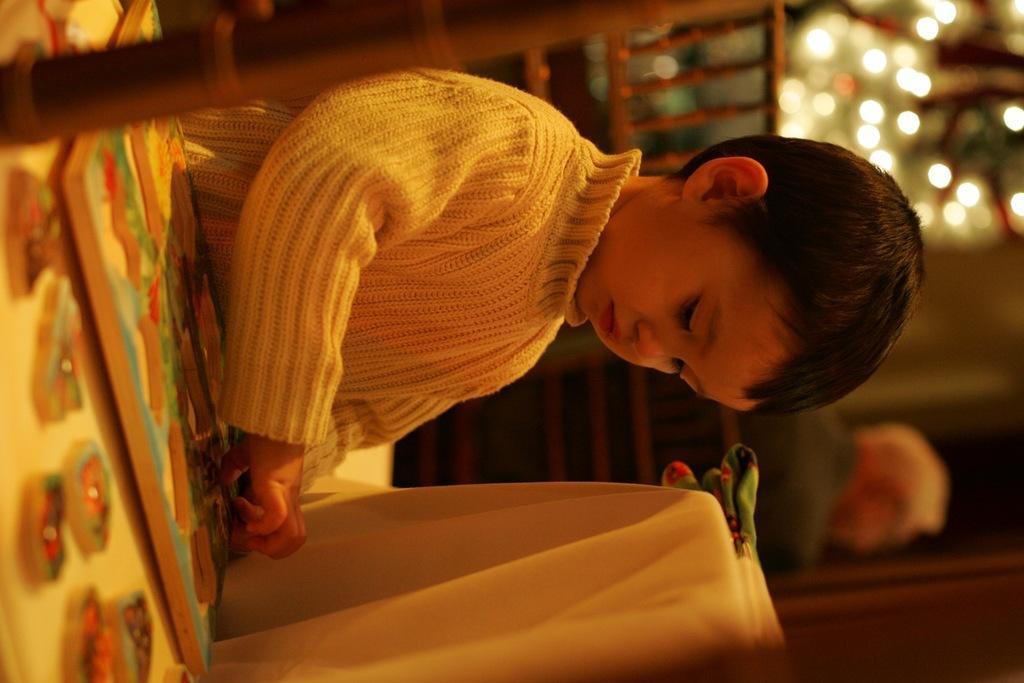Describe this image in one or two sentences. In this image, we can see a kid, in the background we can see some lights. 